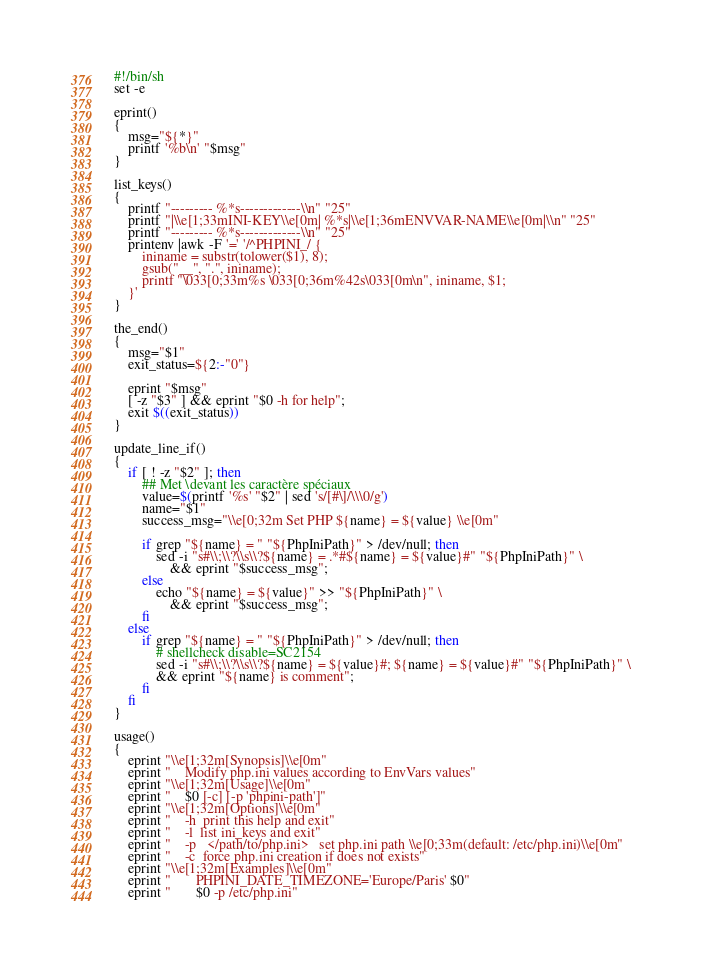Convert code to text. <code><loc_0><loc_0><loc_500><loc_500><_Bash_>#!/bin/sh
set -e

eprint()
{
    msg="${*}"
    printf '%b\n' "$msg"
}

list_keys()
{
    printf "--------- %*s-------------\\n" "25"
    printf "|\\e[1;33mINI-KEY\\e[0m| %*s|\\e[1;36mENVVAR-NAME\\e[0m|\\n" "25"
    printf "--------- %*s-------------\\n" "25"
    printenv |awk -F '=' '/^PHPINI_/ {
        ininame = substr(tolower($1), 8);
        gsub("__", ".", ininame);
        printf "\033[0;33m%s \033[0;36m%42s\033[0m\n", ininame, $1;
    }'
}

the_end()
{
    msg="$1"
    exit_status=${2:-"0"}

    eprint "$msg"
    [ -z "$3" ] && eprint "$0 -h for help";
    exit $((exit_status))
}

update_line_if()
{
    if [ ! -z "$2" ]; then
        ## Met \devant les caractère spéciaux
        value=$(printf '%s' "$2" | sed 's/[#\]/\\\0/g')
        name="$1"
        success_msg="\\e[0;32m Set PHP ${name} = ${value} \\e[0m"

        if grep "${name} = " "${PhpIniPath}" > /dev/null; then
            sed -i "s#\\;\\?\\s\\?${name} = .*#${name} = ${value}#" "${PhpIniPath}" \
                && eprint "$success_msg";
        else
            echo "${name} = ${value}" >> "${PhpIniPath}" \
                && eprint "$success_msg";
        fi
    else
        if grep "${name} = " "${PhpIniPath}" > /dev/null; then
            # shellcheck disable=SC2154
            sed -i "s#\\;\\?\\s\\?${name} = ${value}#; ${name} = ${value}#" "${PhpIniPath}" \
            && eprint "${name} is comment";
        fi
    fi
}

usage()
{
    eprint "\\e[1;32m[Synopsis]\\e[0m"
    eprint "    Modify php.ini values according to EnvVars values"
    eprint "\\e[1;32m[Usage]\\e[0m"
    eprint "    $0 [-c] [-p 'phpini-path']"
    eprint "\\e[1;32m[Options]\\e[0m"
    eprint "    -h  print this help and exit"
    eprint "    -l  list ini_keys and exit"
    eprint "    -p   </path/to/php.ini>   set php.ini path \\e[0;33m(default: /etc/php.ini)\\e[0m"
    eprint "    -c  force php.ini creation if does not exists"
    eprint "\\e[1;32m[Examples]\\e[0m"
    eprint "       PHPINI_DATE_TIMEZONE='Europe/Paris' $0"
    eprint "       $0 -p /etc/php.ini"</code> 